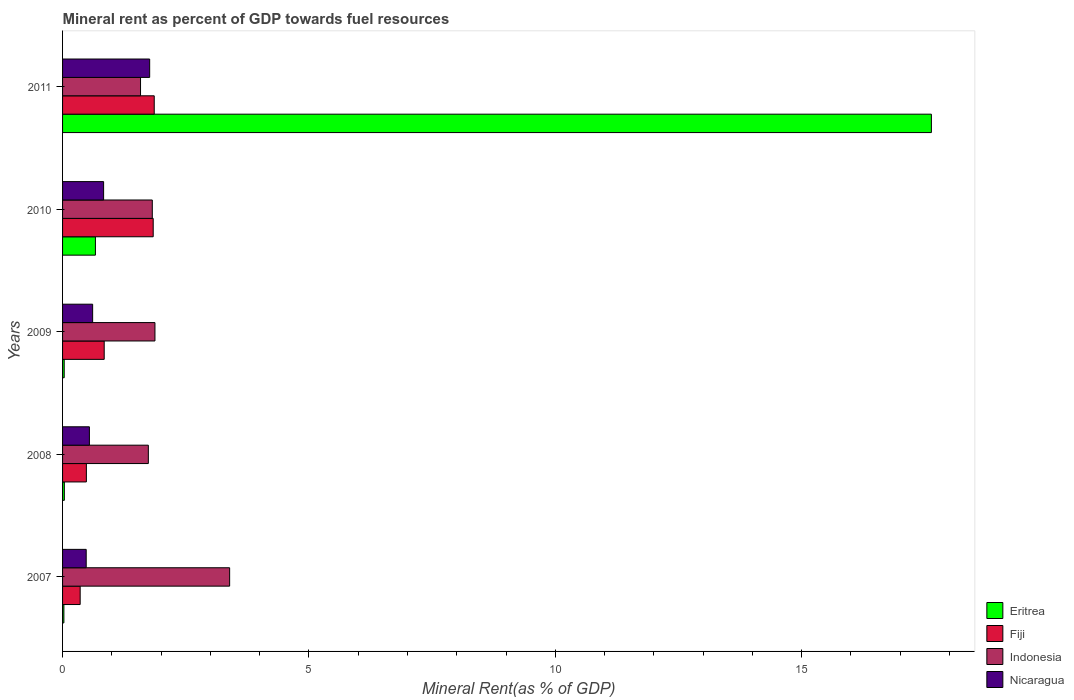How many different coloured bars are there?
Provide a short and direct response. 4. How many groups of bars are there?
Your answer should be compact. 5. Are the number of bars per tick equal to the number of legend labels?
Your answer should be compact. Yes. What is the label of the 5th group of bars from the top?
Give a very brief answer. 2007. What is the mineral rent in Nicaragua in 2010?
Give a very brief answer. 0.83. Across all years, what is the maximum mineral rent in Fiji?
Give a very brief answer. 1.86. Across all years, what is the minimum mineral rent in Nicaragua?
Offer a terse response. 0.48. What is the total mineral rent in Eritrea in the graph?
Keep it short and to the point. 18.4. What is the difference between the mineral rent in Indonesia in 2008 and that in 2009?
Give a very brief answer. -0.13. What is the difference between the mineral rent in Fiji in 2010 and the mineral rent in Nicaragua in 2008?
Give a very brief answer. 1.29. What is the average mineral rent in Nicaragua per year?
Your answer should be compact. 0.85. In the year 2009, what is the difference between the mineral rent in Eritrea and mineral rent in Fiji?
Provide a short and direct response. -0.81. In how many years, is the mineral rent in Nicaragua greater than 4 %?
Keep it short and to the point. 0. What is the ratio of the mineral rent in Eritrea in 2007 to that in 2010?
Your answer should be very brief. 0.04. Is the mineral rent in Nicaragua in 2007 less than that in 2010?
Your answer should be very brief. Yes. Is the difference between the mineral rent in Eritrea in 2008 and 2010 greater than the difference between the mineral rent in Fiji in 2008 and 2010?
Offer a terse response. Yes. What is the difference between the highest and the second highest mineral rent in Nicaragua?
Your answer should be compact. 0.93. What is the difference between the highest and the lowest mineral rent in Fiji?
Provide a succinct answer. 1.5. In how many years, is the mineral rent in Indonesia greater than the average mineral rent in Indonesia taken over all years?
Your response must be concise. 1. What does the 4th bar from the top in 2007 represents?
Keep it short and to the point. Eritrea. What does the 3rd bar from the bottom in 2011 represents?
Keep it short and to the point. Indonesia. Is it the case that in every year, the sum of the mineral rent in Eritrea and mineral rent in Fiji is greater than the mineral rent in Nicaragua?
Your response must be concise. No. What is the difference between two consecutive major ticks on the X-axis?
Provide a succinct answer. 5. Does the graph contain any zero values?
Keep it short and to the point. No. How many legend labels are there?
Give a very brief answer. 4. How are the legend labels stacked?
Give a very brief answer. Vertical. What is the title of the graph?
Make the answer very short. Mineral rent as percent of GDP towards fuel resources. Does "Macedonia" appear as one of the legend labels in the graph?
Make the answer very short. No. What is the label or title of the X-axis?
Keep it short and to the point. Mineral Rent(as % of GDP). What is the label or title of the Y-axis?
Give a very brief answer. Years. What is the Mineral Rent(as % of GDP) in Eritrea in 2007?
Make the answer very short. 0.03. What is the Mineral Rent(as % of GDP) of Fiji in 2007?
Keep it short and to the point. 0.36. What is the Mineral Rent(as % of GDP) in Indonesia in 2007?
Ensure brevity in your answer.  3.39. What is the Mineral Rent(as % of GDP) of Nicaragua in 2007?
Ensure brevity in your answer.  0.48. What is the Mineral Rent(as % of GDP) in Eritrea in 2008?
Provide a short and direct response. 0.04. What is the Mineral Rent(as % of GDP) of Fiji in 2008?
Provide a succinct answer. 0.48. What is the Mineral Rent(as % of GDP) of Indonesia in 2008?
Offer a terse response. 1.74. What is the Mineral Rent(as % of GDP) in Nicaragua in 2008?
Ensure brevity in your answer.  0.54. What is the Mineral Rent(as % of GDP) in Eritrea in 2009?
Provide a short and direct response. 0.03. What is the Mineral Rent(as % of GDP) of Fiji in 2009?
Your answer should be compact. 0.85. What is the Mineral Rent(as % of GDP) in Indonesia in 2009?
Provide a succinct answer. 1.87. What is the Mineral Rent(as % of GDP) of Nicaragua in 2009?
Your answer should be compact. 0.61. What is the Mineral Rent(as % of GDP) of Eritrea in 2010?
Provide a short and direct response. 0.67. What is the Mineral Rent(as % of GDP) of Fiji in 2010?
Keep it short and to the point. 1.84. What is the Mineral Rent(as % of GDP) of Indonesia in 2010?
Offer a terse response. 1.82. What is the Mineral Rent(as % of GDP) of Nicaragua in 2010?
Provide a short and direct response. 0.83. What is the Mineral Rent(as % of GDP) in Eritrea in 2011?
Your answer should be very brief. 17.63. What is the Mineral Rent(as % of GDP) in Fiji in 2011?
Make the answer very short. 1.86. What is the Mineral Rent(as % of GDP) in Indonesia in 2011?
Make the answer very short. 1.58. What is the Mineral Rent(as % of GDP) of Nicaragua in 2011?
Offer a very short reply. 1.77. Across all years, what is the maximum Mineral Rent(as % of GDP) of Eritrea?
Offer a very short reply. 17.63. Across all years, what is the maximum Mineral Rent(as % of GDP) of Fiji?
Your response must be concise. 1.86. Across all years, what is the maximum Mineral Rent(as % of GDP) in Indonesia?
Provide a short and direct response. 3.39. Across all years, what is the maximum Mineral Rent(as % of GDP) in Nicaragua?
Keep it short and to the point. 1.77. Across all years, what is the minimum Mineral Rent(as % of GDP) of Eritrea?
Ensure brevity in your answer.  0.03. Across all years, what is the minimum Mineral Rent(as % of GDP) in Fiji?
Keep it short and to the point. 0.36. Across all years, what is the minimum Mineral Rent(as % of GDP) in Indonesia?
Ensure brevity in your answer.  1.58. Across all years, what is the minimum Mineral Rent(as % of GDP) of Nicaragua?
Make the answer very short. 0.48. What is the total Mineral Rent(as % of GDP) of Eritrea in the graph?
Keep it short and to the point. 18.4. What is the total Mineral Rent(as % of GDP) of Fiji in the graph?
Your answer should be compact. 5.39. What is the total Mineral Rent(as % of GDP) of Indonesia in the graph?
Your response must be concise. 10.41. What is the total Mineral Rent(as % of GDP) in Nicaragua in the graph?
Make the answer very short. 4.24. What is the difference between the Mineral Rent(as % of GDP) of Eritrea in 2007 and that in 2008?
Your response must be concise. -0.01. What is the difference between the Mineral Rent(as % of GDP) in Fiji in 2007 and that in 2008?
Make the answer very short. -0.13. What is the difference between the Mineral Rent(as % of GDP) of Indonesia in 2007 and that in 2008?
Offer a very short reply. 1.65. What is the difference between the Mineral Rent(as % of GDP) in Nicaragua in 2007 and that in 2008?
Ensure brevity in your answer.  -0.06. What is the difference between the Mineral Rent(as % of GDP) of Eritrea in 2007 and that in 2009?
Give a very brief answer. -0.01. What is the difference between the Mineral Rent(as % of GDP) of Fiji in 2007 and that in 2009?
Keep it short and to the point. -0.49. What is the difference between the Mineral Rent(as % of GDP) of Indonesia in 2007 and that in 2009?
Provide a succinct answer. 1.52. What is the difference between the Mineral Rent(as % of GDP) of Nicaragua in 2007 and that in 2009?
Your answer should be very brief. -0.13. What is the difference between the Mineral Rent(as % of GDP) of Eritrea in 2007 and that in 2010?
Your answer should be very brief. -0.64. What is the difference between the Mineral Rent(as % of GDP) of Fiji in 2007 and that in 2010?
Provide a short and direct response. -1.48. What is the difference between the Mineral Rent(as % of GDP) of Indonesia in 2007 and that in 2010?
Offer a very short reply. 1.57. What is the difference between the Mineral Rent(as % of GDP) in Nicaragua in 2007 and that in 2010?
Make the answer very short. -0.35. What is the difference between the Mineral Rent(as % of GDP) in Eritrea in 2007 and that in 2011?
Your response must be concise. -17.61. What is the difference between the Mineral Rent(as % of GDP) in Fiji in 2007 and that in 2011?
Offer a very short reply. -1.5. What is the difference between the Mineral Rent(as % of GDP) of Indonesia in 2007 and that in 2011?
Make the answer very short. 1.81. What is the difference between the Mineral Rent(as % of GDP) of Nicaragua in 2007 and that in 2011?
Your answer should be compact. -1.29. What is the difference between the Mineral Rent(as % of GDP) in Eritrea in 2008 and that in 2009?
Give a very brief answer. 0. What is the difference between the Mineral Rent(as % of GDP) of Fiji in 2008 and that in 2009?
Your response must be concise. -0.36. What is the difference between the Mineral Rent(as % of GDP) of Indonesia in 2008 and that in 2009?
Your answer should be compact. -0.13. What is the difference between the Mineral Rent(as % of GDP) in Nicaragua in 2008 and that in 2009?
Your answer should be compact. -0.07. What is the difference between the Mineral Rent(as % of GDP) in Eritrea in 2008 and that in 2010?
Your answer should be very brief. -0.63. What is the difference between the Mineral Rent(as % of GDP) in Fiji in 2008 and that in 2010?
Your response must be concise. -1.36. What is the difference between the Mineral Rent(as % of GDP) in Indonesia in 2008 and that in 2010?
Give a very brief answer. -0.08. What is the difference between the Mineral Rent(as % of GDP) of Nicaragua in 2008 and that in 2010?
Your answer should be very brief. -0.29. What is the difference between the Mineral Rent(as % of GDP) in Eritrea in 2008 and that in 2011?
Offer a very short reply. -17.6. What is the difference between the Mineral Rent(as % of GDP) in Fiji in 2008 and that in 2011?
Provide a succinct answer. -1.38. What is the difference between the Mineral Rent(as % of GDP) of Indonesia in 2008 and that in 2011?
Your answer should be compact. 0.16. What is the difference between the Mineral Rent(as % of GDP) of Nicaragua in 2008 and that in 2011?
Your response must be concise. -1.22. What is the difference between the Mineral Rent(as % of GDP) in Eritrea in 2009 and that in 2010?
Provide a short and direct response. -0.63. What is the difference between the Mineral Rent(as % of GDP) of Fiji in 2009 and that in 2010?
Provide a succinct answer. -0.99. What is the difference between the Mineral Rent(as % of GDP) of Indonesia in 2009 and that in 2010?
Make the answer very short. 0.05. What is the difference between the Mineral Rent(as % of GDP) of Nicaragua in 2009 and that in 2010?
Provide a short and direct response. -0.22. What is the difference between the Mineral Rent(as % of GDP) of Eritrea in 2009 and that in 2011?
Offer a very short reply. -17.6. What is the difference between the Mineral Rent(as % of GDP) of Fiji in 2009 and that in 2011?
Provide a short and direct response. -1.02. What is the difference between the Mineral Rent(as % of GDP) of Indonesia in 2009 and that in 2011?
Ensure brevity in your answer.  0.29. What is the difference between the Mineral Rent(as % of GDP) of Nicaragua in 2009 and that in 2011?
Ensure brevity in your answer.  -1.16. What is the difference between the Mineral Rent(as % of GDP) in Eritrea in 2010 and that in 2011?
Your answer should be compact. -16.97. What is the difference between the Mineral Rent(as % of GDP) of Fiji in 2010 and that in 2011?
Keep it short and to the point. -0.02. What is the difference between the Mineral Rent(as % of GDP) in Indonesia in 2010 and that in 2011?
Provide a succinct answer. 0.24. What is the difference between the Mineral Rent(as % of GDP) in Nicaragua in 2010 and that in 2011?
Give a very brief answer. -0.93. What is the difference between the Mineral Rent(as % of GDP) in Eritrea in 2007 and the Mineral Rent(as % of GDP) in Fiji in 2008?
Offer a very short reply. -0.46. What is the difference between the Mineral Rent(as % of GDP) in Eritrea in 2007 and the Mineral Rent(as % of GDP) in Indonesia in 2008?
Make the answer very short. -1.71. What is the difference between the Mineral Rent(as % of GDP) in Eritrea in 2007 and the Mineral Rent(as % of GDP) in Nicaragua in 2008?
Keep it short and to the point. -0.52. What is the difference between the Mineral Rent(as % of GDP) in Fiji in 2007 and the Mineral Rent(as % of GDP) in Indonesia in 2008?
Your response must be concise. -1.38. What is the difference between the Mineral Rent(as % of GDP) in Fiji in 2007 and the Mineral Rent(as % of GDP) in Nicaragua in 2008?
Offer a terse response. -0.19. What is the difference between the Mineral Rent(as % of GDP) in Indonesia in 2007 and the Mineral Rent(as % of GDP) in Nicaragua in 2008?
Offer a very short reply. 2.85. What is the difference between the Mineral Rent(as % of GDP) in Eritrea in 2007 and the Mineral Rent(as % of GDP) in Fiji in 2009?
Your answer should be very brief. -0.82. What is the difference between the Mineral Rent(as % of GDP) of Eritrea in 2007 and the Mineral Rent(as % of GDP) of Indonesia in 2009?
Offer a terse response. -1.85. What is the difference between the Mineral Rent(as % of GDP) in Eritrea in 2007 and the Mineral Rent(as % of GDP) in Nicaragua in 2009?
Provide a short and direct response. -0.58. What is the difference between the Mineral Rent(as % of GDP) in Fiji in 2007 and the Mineral Rent(as % of GDP) in Indonesia in 2009?
Provide a short and direct response. -1.52. What is the difference between the Mineral Rent(as % of GDP) of Fiji in 2007 and the Mineral Rent(as % of GDP) of Nicaragua in 2009?
Offer a very short reply. -0.25. What is the difference between the Mineral Rent(as % of GDP) of Indonesia in 2007 and the Mineral Rent(as % of GDP) of Nicaragua in 2009?
Make the answer very short. 2.78. What is the difference between the Mineral Rent(as % of GDP) in Eritrea in 2007 and the Mineral Rent(as % of GDP) in Fiji in 2010?
Your answer should be very brief. -1.81. What is the difference between the Mineral Rent(as % of GDP) in Eritrea in 2007 and the Mineral Rent(as % of GDP) in Indonesia in 2010?
Offer a terse response. -1.79. What is the difference between the Mineral Rent(as % of GDP) of Eritrea in 2007 and the Mineral Rent(as % of GDP) of Nicaragua in 2010?
Provide a succinct answer. -0.81. What is the difference between the Mineral Rent(as % of GDP) in Fiji in 2007 and the Mineral Rent(as % of GDP) in Indonesia in 2010?
Make the answer very short. -1.46. What is the difference between the Mineral Rent(as % of GDP) in Fiji in 2007 and the Mineral Rent(as % of GDP) in Nicaragua in 2010?
Ensure brevity in your answer.  -0.48. What is the difference between the Mineral Rent(as % of GDP) of Indonesia in 2007 and the Mineral Rent(as % of GDP) of Nicaragua in 2010?
Offer a terse response. 2.56. What is the difference between the Mineral Rent(as % of GDP) of Eritrea in 2007 and the Mineral Rent(as % of GDP) of Fiji in 2011?
Provide a succinct answer. -1.83. What is the difference between the Mineral Rent(as % of GDP) in Eritrea in 2007 and the Mineral Rent(as % of GDP) in Indonesia in 2011?
Provide a succinct answer. -1.56. What is the difference between the Mineral Rent(as % of GDP) in Eritrea in 2007 and the Mineral Rent(as % of GDP) in Nicaragua in 2011?
Provide a short and direct response. -1.74. What is the difference between the Mineral Rent(as % of GDP) in Fiji in 2007 and the Mineral Rent(as % of GDP) in Indonesia in 2011?
Make the answer very short. -1.23. What is the difference between the Mineral Rent(as % of GDP) in Fiji in 2007 and the Mineral Rent(as % of GDP) in Nicaragua in 2011?
Your response must be concise. -1.41. What is the difference between the Mineral Rent(as % of GDP) in Indonesia in 2007 and the Mineral Rent(as % of GDP) in Nicaragua in 2011?
Offer a terse response. 1.62. What is the difference between the Mineral Rent(as % of GDP) in Eritrea in 2008 and the Mineral Rent(as % of GDP) in Fiji in 2009?
Make the answer very short. -0.81. What is the difference between the Mineral Rent(as % of GDP) of Eritrea in 2008 and the Mineral Rent(as % of GDP) of Indonesia in 2009?
Keep it short and to the point. -1.84. What is the difference between the Mineral Rent(as % of GDP) of Eritrea in 2008 and the Mineral Rent(as % of GDP) of Nicaragua in 2009?
Your response must be concise. -0.57. What is the difference between the Mineral Rent(as % of GDP) in Fiji in 2008 and the Mineral Rent(as % of GDP) in Indonesia in 2009?
Offer a very short reply. -1.39. What is the difference between the Mineral Rent(as % of GDP) of Fiji in 2008 and the Mineral Rent(as % of GDP) of Nicaragua in 2009?
Offer a terse response. -0.13. What is the difference between the Mineral Rent(as % of GDP) in Indonesia in 2008 and the Mineral Rent(as % of GDP) in Nicaragua in 2009?
Ensure brevity in your answer.  1.13. What is the difference between the Mineral Rent(as % of GDP) in Eritrea in 2008 and the Mineral Rent(as % of GDP) in Fiji in 2010?
Keep it short and to the point. -1.8. What is the difference between the Mineral Rent(as % of GDP) of Eritrea in 2008 and the Mineral Rent(as % of GDP) of Indonesia in 2010?
Provide a succinct answer. -1.79. What is the difference between the Mineral Rent(as % of GDP) of Eritrea in 2008 and the Mineral Rent(as % of GDP) of Nicaragua in 2010?
Ensure brevity in your answer.  -0.8. What is the difference between the Mineral Rent(as % of GDP) in Fiji in 2008 and the Mineral Rent(as % of GDP) in Indonesia in 2010?
Provide a short and direct response. -1.34. What is the difference between the Mineral Rent(as % of GDP) of Fiji in 2008 and the Mineral Rent(as % of GDP) of Nicaragua in 2010?
Keep it short and to the point. -0.35. What is the difference between the Mineral Rent(as % of GDP) of Indonesia in 2008 and the Mineral Rent(as % of GDP) of Nicaragua in 2010?
Ensure brevity in your answer.  0.91. What is the difference between the Mineral Rent(as % of GDP) of Eritrea in 2008 and the Mineral Rent(as % of GDP) of Fiji in 2011?
Give a very brief answer. -1.82. What is the difference between the Mineral Rent(as % of GDP) in Eritrea in 2008 and the Mineral Rent(as % of GDP) in Indonesia in 2011?
Provide a succinct answer. -1.55. What is the difference between the Mineral Rent(as % of GDP) of Eritrea in 2008 and the Mineral Rent(as % of GDP) of Nicaragua in 2011?
Give a very brief answer. -1.73. What is the difference between the Mineral Rent(as % of GDP) of Fiji in 2008 and the Mineral Rent(as % of GDP) of Indonesia in 2011?
Your answer should be very brief. -1.1. What is the difference between the Mineral Rent(as % of GDP) in Fiji in 2008 and the Mineral Rent(as % of GDP) in Nicaragua in 2011?
Make the answer very short. -1.28. What is the difference between the Mineral Rent(as % of GDP) of Indonesia in 2008 and the Mineral Rent(as % of GDP) of Nicaragua in 2011?
Make the answer very short. -0.03. What is the difference between the Mineral Rent(as % of GDP) in Eritrea in 2009 and the Mineral Rent(as % of GDP) in Fiji in 2010?
Keep it short and to the point. -1.81. What is the difference between the Mineral Rent(as % of GDP) in Eritrea in 2009 and the Mineral Rent(as % of GDP) in Indonesia in 2010?
Your answer should be very brief. -1.79. What is the difference between the Mineral Rent(as % of GDP) of Fiji in 2009 and the Mineral Rent(as % of GDP) of Indonesia in 2010?
Make the answer very short. -0.98. What is the difference between the Mineral Rent(as % of GDP) of Fiji in 2009 and the Mineral Rent(as % of GDP) of Nicaragua in 2010?
Offer a very short reply. 0.01. What is the difference between the Mineral Rent(as % of GDP) of Indonesia in 2009 and the Mineral Rent(as % of GDP) of Nicaragua in 2010?
Offer a terse response. 1.04. What is the difference between the Mineral Rent(as % of GDP) in Eritrea in 2009 and the Mineral Rent(as % of GDP) in Fiji in 2011?
Ensure brevity in your answer.  -1.83. What is the difference between the Mineral Rent(as % of GDP) of Eritrea in 2009 and the Mineral Rent(as % of GDP) of Indonesia in 2011?
Give a very brief answer. -1.55. What is the difference between the Mineral Rent(as % of GDP) of Eritrea in 2009 and the Mineral Rent(as % of GDP) of Nicaragua in 2011?
Provide a short and direct response. -1.73. What is the difference between the Mineral Rent(as % of GDP) in Fiji in 2009 and the Mineral Rent(as % of GDP) in Indonesia in 2011?
Offer a very short reply. -0.74. What is the difference between the Mineral Rent(as % of GDP) in Fiji in 2009 and the Mineral Rent(as % of GDP) in Nicaragua in 2011?
Keep it short and to the point. -0.92. What is the difference between the Mineral Rent(as % of GDP) of Indonesia in 2009 and the Mineral Rent(as % of GDP) of Nicaragua in 2011?
Give a very brief answer. 0.11. What is the difference between the Mineral Rent(as % of GDP) in Eritrea in 2010 and the Mineral Rent(as % of GDP) in Fiji in 2011?
Provide a short and direct response. -1.19. What is the difference between the Mineral Rent(as % of GDP) in Eritrea in 2010 and the Mineral Rent(as % of GDP) in Indonesia in 2011?
Your response must be concise. -0.92. What is the difference between the Mineral Rent(as % of GDP) in Eritrea in 2010 and the Mineral Rent(as % of GDP) in Nicaragua in 2011?
Make the answer very short. -1.1. What is the difference between the Mineral Rent(as % of GDP) of Fiji in 2010 and the Mineral Rent(as % of GDP) of Indonesia in 2011?
Your answer should be compact. 0.26. What is the difference between the Mineral Rent(as % of GDP) in Fiji in 2010 and the Mineral Rent(as % of GDP) in Nicaragua in 2011?
Ensure brevity in your answer.  0.07. What is the difference between the Mineral Rent(as % of GDP) of Indonesia in 2010 and the Mineral Rent(as % of GDP) of Nicaragua in 2011?
Offer a very short reply. 0.05. What is the average Mineral Rent(as % of GDP) of Eritrea per year?
Provide a succinct answer. 3.68. What is the average Mineral Rent(as % of GDP) in Fiji per year?
Your answer should be very brief. 1.08. What is the average Mineral Rent(as % of GDP) of Indonesia per year?
Your answer should be very brief. 2.08. What is the average Mineral Rent(as % of GDP) in Nicaragua per year?
Ensure brevity in your answer.  0.85. In the year 2007, what is the difference between the Mineral Rent(as % of GDP) in Eritrea and Mineral Rent(as % of GDP) in Fiji?
Give a very brief answer. -0.33. In the year 2007, what is the difference between the Mineral Rent(as % of GDP) in Eritrea and Mineral Rent(as % of GDP) in Indonesia?
Offer a very short reply. -3.36. In the year 2007, what is the difference between the Mineral Rent(as % of GDP) in Eritrea and Mineral Rent(as % of GDP) in Nicaragua?
Ensure brevity in your answer.  -0.45. In the year 2007, what is the difference between the Mineral Rent(as % of GDP) of Fiji and Mineral Rent(as % of GDP) of Indonesia?
Ensure brevity in your answer.  -3.03. In the year 2007, what is the difference between the Mineral Rent(as % of GDP) of Fiji and Mineral Rent(as % of GDP) of Nicaragua?
Your answer should be compact. -0.12. In the year 2007, what is the difference between the Mineral Rent(as % of GDP) in Indonesia and Mineral Rent(as % of GDP) in Nicaragua?
Offer a very short reply. 2.91. In the year 2008, what is the difference between the Mineral Rent(as % of GDP) of Eritrea and Mineral Rent(as % of GDP) of Fiji?
Your response must be concise. -0.45. In the year 2008, what is the difference between the Mineral Rent(as % of GDP) in Eritrea and Mineral Rent(as % of GDP) in Indonesia?
Give a very brief answer. -1.7. In the year 2008, what is the difference between the Mineral Rent(as % of GDP) of Eritrea and Mineral Rent(as % of GDP) of Nicaragua?
Keep it short and to the point. -0.51. In the year 2008, what is the difference between the Mineral Rent(as % of GDP) in Fiji and Mineral Rent(as % of GDP) in Indonesia?
Give a very brief answer. -1.26. In the year 2008, what is the difference between the Mineral Rent(as % of GDP) in Fiji and Mineral Rent(as % of GDP) in Nicaragua?
Keep it short and to the point. -0.06. In the year 2008, what is the difference between the Mineral Rent(as % of GDP) of Indonesia and Mineral Rent(as % of GDP) of Nicaragua?
Provide a succinct answer. 1.2. In the year 2009, what is the difference between the Mineral Rent(as % of GDP) of Eritrea and Mineral Rent(as % of GDP) of Fiji?
Keep it short and to the point. -0.81. In the year 2009, what is the difference between the Mineral Rent(as % of GDP) of Eritrea and Mineral Rent(as % of GDP) of Indonesia?
Ensure brevity in your answer.  -1.84. In the year 2009, what is the difference between the Mineral Rent(as % of GDP) of Eritrea and Mineral Rent(as % of GDP) of Nicaragua?
Offer a terse response. -0.58. In the year 2009, what is the difference between the Mineral Rent(as % of GDP) in Fiji and Mineral Rent(as % of GDP) in Indonesia?
Give a very brief answer. -1.03. In the year 2009, what is the difference between the Mineral Rent(as % of GDP) in Fiji and Mineral Rent(as % of GDP) in Nicaragua?
Offer a very short reply. 0.23. In the year 2009, what is the difference between the Mineral Rent(as % of GDP) in Indonesia and Mineral Rent(as % of GDP) in Nicaragua?
Offer a terse response. 1.26. In the year 2010, what is the difference between the Mineral Rent(as % of GDP) of Eritrea and Mineral Rent(as % of GDP) of Fiji?
Make the answer very short. -1.17. In the year 2010, what is the difference between the Mineral Rent(as % of GDP) in Eritrea and Mineral Rent(as % of GDP) in Indonesia?
Your answer should be very brief. -1.15. In the year 2010, what is the difference between the Mineral Rent(as % of GDP) of Eritrea and Mineral Rent(as % of GDP) of Nicaragua?
Give a very brief answer. -0.17. In the year 2010, what is the difference between the Mineral Rent(as % of GDP) in Fiji and Mineral Rent(as % of GDP) in Indonesia?
Your answer should be very brief. 0.02. In the year 2010, what is the difference between the Mineral Rent(as % of GDP) in Indonesia and Mineral Rent(as % of GDP) in Nicaragua?
Provide a short and direct response. 0.99. In the year 2011, what is the difference between the Mineral Rent(as % of GDP) of Eritrea and Mineral Rent(as % of GDP) of Fiji?
Offer a terse response. 15.77. In the year 2011, what is the difference between the Mineral Rent(as % of GDP) in Eritrea and Mineral Rent(as % of GDP) in Indonesia?
Provide a short and direct response. 16.05. In the year 2011, what is the difference between the Mineral Rent(as % of GDP) in Eritrea and Mineral Rent(as % of GDP) in Nicaragua?
Give a very brief answer. 15.87. In the year 2011, what is the difference between the Mineral Rent(as % of GDP) in Fiji and Mineral Rent(as % of GDP) in Indonesia?
Provide a succinct answer. 0.28. In the year 2011, what is the difference between the Mineral Rent(as % of GDP) of Fiji and Mineral Rent(as % of GDP) of Nicaragua?
Give a very brief answer. 0.09. In the year 2011, what is the difference between the Mineral Rent(as % of GDP) in Indonesia and Mineral Rent(as % of GDP) in Nicaragua?
Offer a very short reply. -0.19. What is the ratio of the Mineral Rent(as % of GDP) of Eritrea in 2007 to that in 2008?
Keep it short and to the point. 0.74. What is the ratio of the Mineral Rent(as % of GDP) of Fiji in 2007 to that in 2008?
Provide a short and direct response. 0.74. What is the ratio of the Mineral Rent(as % of GDP) in Indonesia in 2007 to that in 2008?
Your answer should be compact. 1.95. What is the ratio of the Mineral Rent(as % of GDP) in Nicaragua in 2007 to that in 2008?
Ensure brevity in your answer.  0.88. What is the ratio of the Mineral Rent(as % of GDP) of Eritrea in 2007 to that in 2009?
Your answer should be very brief. 0.81. What is the ratio of the Mineral Rent(as % of GDP) in Fiji in 2007 to that in 2009?
Keep it short and to the point. 0.42. What is the ratio of the Mineral Rent(as % of GDP) of Indonesia in 2007 to that in 2009?
Provide a succinct answer. 1.81. What is the ratio of the Mineral Rent(as % of GDP) in Nicaragua in 2007 to that in 2009?
Provide a short and direct response. 0.79. What is the ratio of the Mineral Rent(as % of GDP) of Eritrea in 2007 to that in 2010?
Provide a short and direct response. 0.04. What is the ratio of the Mineral Rent(as % of GDP) in Fiji in 2007 to that in 2010?
Your response must be concise. 0.19. What is the ratio of the Mineral Rent(as % of GDP) in Indonesia in 2007 to that in 2010?
Provide a succinct answer. 1.86. What is the ratio of the Mineral Rent(as % of GDP) in Nicaragua in 2007 to that in 2010?
Your answer should be very brief. 0.58. What is the ratio of the Mineral Rent(as % of GDP) in Eritrea in 2007 to that in 2011?
Offer a terse response. 0. What is the ratio of the Mineral Rent(as % of GDP) in Fiji in 2007 to that in 2011?
Your answer should be compact. 0.19. What is the ratio of the Mineral Rent(as % of GDP) in Indonesia in 2007 to that in 2011?
Give a very brief answer. 2.14. What is the ratio of the Mineral Rent(as % of GDP) of Nicaragua in 2007 to that in 2011?
Ensure brevity in your answer.  0.27. What is the ratio of the Mineral Rent(as % of GDP) of Eritrea in 2008 to that in 2009?
Offer a very short reply. 1.09. What is the ratio of the Mineral Rent(as % of GDP) in Fiji in 2008 to that in 2009?
Ensure brevity in your answer.  0.57. What is the ratio of the Mineral Rent(as % of GDP) of Indonesia in 2008 to that in 2009?
Make the answer very short. 0.93. What is the ratio of the Mineral Rent(as % of GDP) in Nicaragua in 2008 to that in 2009?
Keep it short and to the point. 0.89. What is the ratio of the Mineral Rent(as % of GDP) in Eritrea in 2008 to that in 2010?
Make the answer very short. 0.05. What is the ratio of the Mineral Rent(as % of GDP) in Fiji in 2008 to that in 2010?
Your answer should be compact. 0.26. What is the ratio of the Mineral Rent(as % of GDP) in Indonesia in 2008 to that in 2010?
Ensure brevity in your answer.  0.96. What is the ratio of the Mineral Rent(as % of GDP) of Nicaragua in 2008 to that in 2010?
Give a very brief answer. 0.65. What is the ratio of the Mineral Rent(as % of GDP) of Eritrea in 2008 to that in 2011?
Make the answer very short. 0. What is the ratio of the Mineral Rent(as % of GDP) of Fiji in 2008 to that in 2011?
Make the answer very short. 0.26. What is the ratio of the Mineral Rent(as % of GDP) in Indonesia in 2008 to that in 2011?
Offer a very short reply. 1.1. What is the ratio of the Mineral Rent(as % of GDP) in Nicaragua in 2008 to that in 2011?
Provide a short and direct response. 0.31. What is the ratio of the Mineral Rent(as % of GDP) of Eritrea in 2009 to that in 2010?
Keep it short and to the point. 0.05. What is the ratio of the Mineral Rent(as % of GDP) in Fiji in 2009 to that in 2010?
Give a very brief answer. 0.46. What is the ratio of the Mineral Rent(as % of GDP) of Indonesia in 2009 to that in 2010?
Make the answer very short. 1.03. What is the ratio of the Mineral Rent(as % of GDP) in Nicaragua in 2009 to that in 2010?
Offer a terse response. 0.73. What is the ratio of the Mineral Rent(as % of GDP) of Eritrea in 2009 to that in 2011?
Your answer should be very brief. 0. What is the ratio of the Mineral Rent(as % of GDP) of Fiji in 2009 to that in 2011?
Your response must be concise. 0.45. What is the ratio of the Mineral Rent(as % of GDP) of Indonesia in 2009 to that in 2011?
Provide a succinct answer. 1.19. What is the ratio of the Mineral Rent(as % of GDP) in Nicaragua in 2009 to that in 2011?
Provide a succinct answer. 0.35. What is the ratio of the Mineral Rent(as % of GDP) of Eritrea in 2010 to that in 2011?
Provide a short and direct response. 0.04. What is the ratio of the Mineral Rent(as % of GDP) of Fiji in 2010 to that in 2011?
Keep it short and to the point. 0.99. What is the ratio of the Mineral Rent(as % of GDP) of Indonesia in 2010 to that in 2011?
Provide a succinct answer. 1.15. What is the ratio of the Mineral Rent(as % of GDP) in Nicaragua in 2010 to that in 2011?
Ensure brevity in your answer.  0.47. What is the difference between the highest and the second highest Mineral Rent(as % of GDP) in Eritrea?
Give a very brief answer. 16.97. What is the difference between the highest and the second highest Mineral Rent(as % of GDP) of Fiji?
Provide a short and direct response. 0.02. What is the difference between the highest and the second highest Mineral Rent(as % of GDP) in Indonesia?
Provide a succinct answer. 1.52. What is the difference between the highest and the second highest Mineral Rent(as % of GDP) of Nicaragua?
Offer a terse response. 0.93. What is the difference between the highest and the lowest Mineral Rent(as % of GDP) in Eritrea?
Your answer should be very brief. 17.61. What is the difference between the highest and the lowest Mineral Rent(as % of GDP) in Fiji?
Offer a very short reply. 1.5. What is the difference between the highest and the lowest Mineral Rent(as % of GDP) in Indonesia?
Offer a very short reply. 1.81. What is the difference between the highest and the lowest Mineral Rent(as % of GDP) of Nicaragua?
Your answer should be compact. 1.29. 